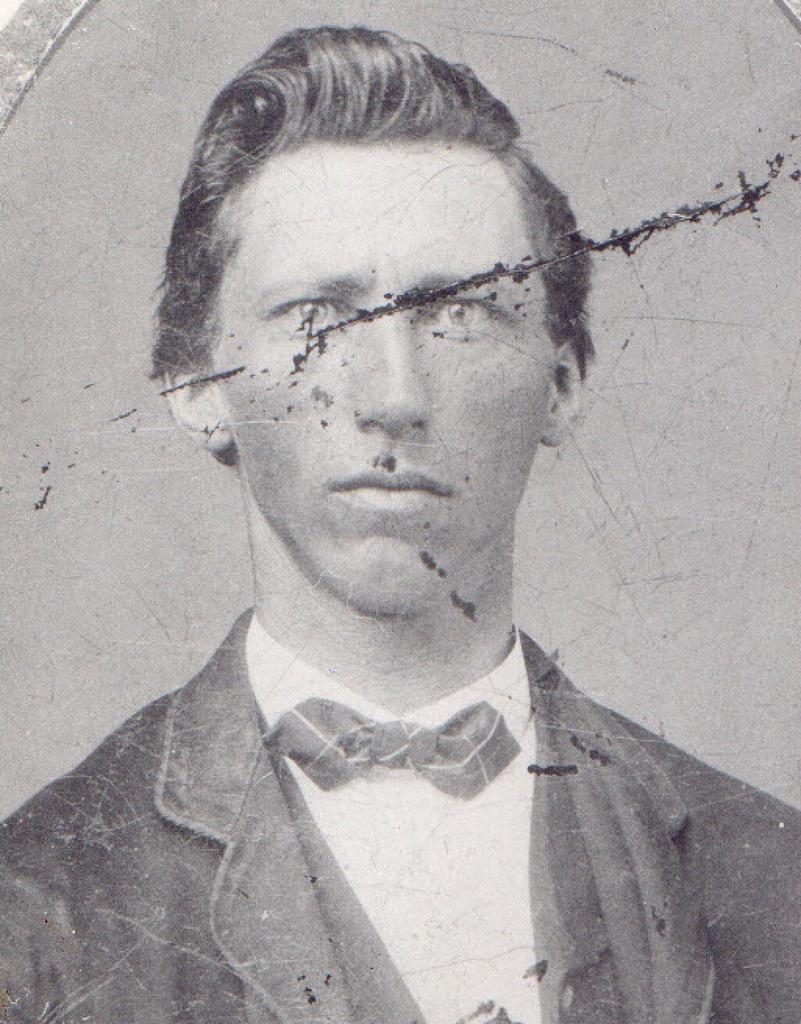Please provide a concise description of this image. This is an old black and white image. I can see the man with suit, shirt and a bowl. 